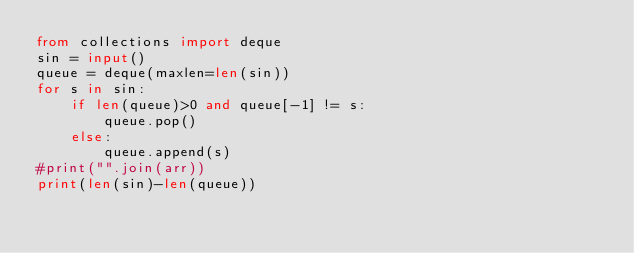Convert code to text. <code><loc_0><loc_0><loc_500><loc_500><_Python_>from collections import deque
sin = input()
queue = deque(maxlen=len(sin))
for s in sin:
    if len(queue)>0 and queue[-1] != s:
        queue.pop()
    else:
        queue.append(s)
#print("".join(arr))
print(len(sin)-len(queue))</code> 